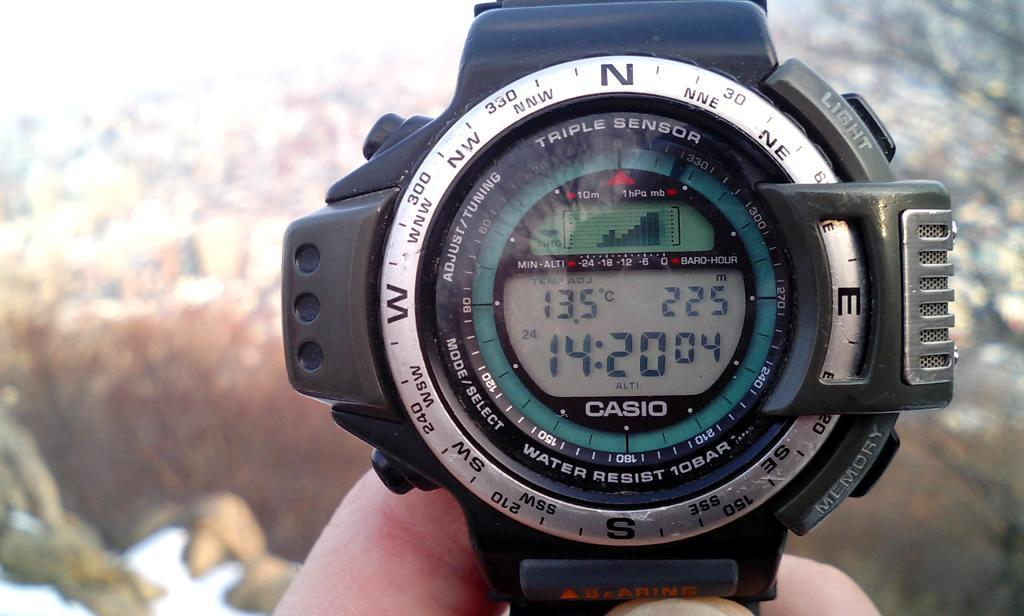<image>
Share a concise interpretation of the image provided. A casio digital watch shows that the time is 14:20. 